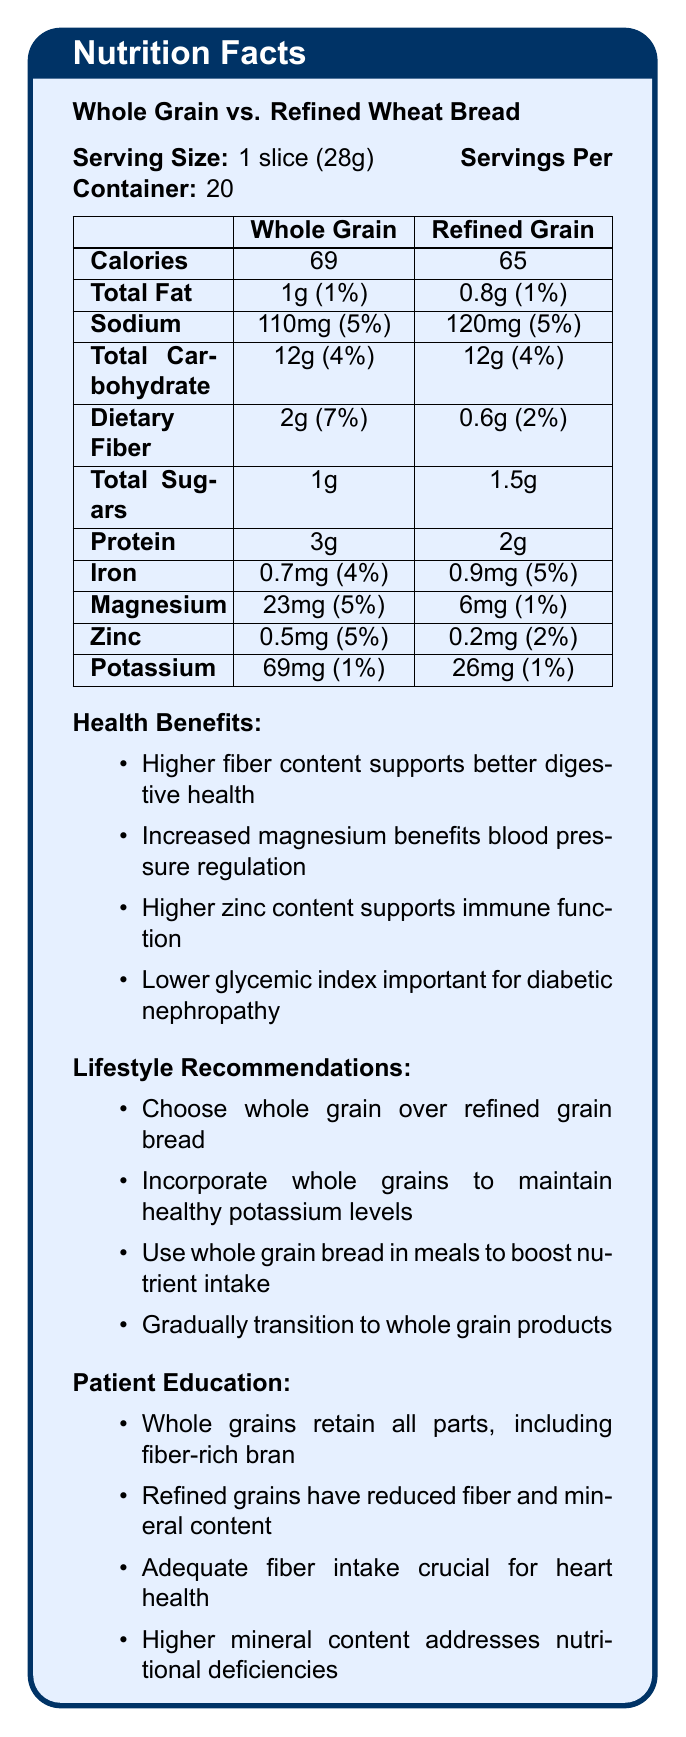what is the serving size for both whole grain and refined grain bread? The serving size is clearly stated as 1 slice (28g) for both whole grain and refined grain bread at the beginning of the document.
Answer: 1 slice (28g) how much dietary fiber does whole grain bread contain per serving? The document states that whole grain bread contains 2g of dietary fiber per serving in the Nutrition Facts table.
Answer: 2g how many calories are in a serving of refined grain bread? The Nutrition Facts table indicates that a serving of refined grain bread contains 65 calories.
Answer: 65 calories what percentage of daily magnesium intake does whole grain bread provide? The document states that whole grain bread provides 5% of the daily value of magnesium per serving.
Answer: 5% compare the sodium content of whole grain bread with refined grain bread. The Nutrition Facts table shows that whole grain bread contains 110mg of sodium (5% of the daily value), whereas refined grain bread contains 120mg of sodium (5% of the daily value).
Answer: Whole grain bread: 110mg (5%), Refined grain bread: 120mg (5%) which type of bread is recommended for maintaining healthy potassium levels? A. Whole grain bread B. Refined grain bread C. Both D. Neither Under Lifestyle Recommendations, it is suggested to incorporate whole grain products into meals to help maintain healthy potassium levels.
Answer: A. Whole grain bread what is one of the health benefits of choosing whole grain bread over refined grain bread? A. Higher sugar content B. Higher glycemic index C. Better digestive health D. Higher calorie content The Health Benefits section highlights that the higher fiber content in whole grain bread supports better digestive health.
Answer: C. Better digestive health does whole grain bread provide more protein than refined grain bread? According to the Nutrition Facts table, whole grain bread contains 3g of protein per serving, while refined grain bread contains 2g of protein.
Answer: Yes what are some points covered in the Patient Education section about whole grain and refined grain products? The Patient Education section emphasizes the retention of bran and germ in whole grains, the reduction of fiber and minerals in refined grains, the importance of fiber for heart health, and the mineral benefits for kidney patients.
Answer: Whole grains retain fiber-rich bran and nutrient-dense germ, whereas refined grains have these parts removed, reducing fiber and mineral content; adequate fiber intake helps maintain healthy cholesterol levels; higher mineral content in whole grains helps address deficiencies in chronic kidney disease patients. what type of bread has a lower glycemic index and why is this important for some patients? The Health Benefits section notes that whole grain bread has a lower glycemic index which is crucial for patients with diabetic nephropathy.
Answer: Whole grain bread; important for diabetic nephropathy patients how much iron does refined grain bread contain per serving? The document states that refined grain bread contains 0.9mg of iron per serving, which is 5% of the daily value.
Answer: 0.9mg (5%) can the exact ratios of serving size to protein content for both types of bread be determined from the document? While the protein content per serving is provided, the document does not provide the data necessary to calculate the exact ratio accurately beyond simple division.
Answer: Not enough information summarize the main differences between whole grain and refined grain bread as presented in the document. The document contrasts the nutritional content and health benefits of whole grain versus refined grain bread, focusing on whole grain’s superior fiber, mineral content, and lower glycemic index. It offers health benefits, lifestyle recommendations, and educational points aimed at promoting whole grain bread for kidney health and overall wellness.
Answer: Whole grain bread has higher fiber, magnesium, zinc, and potassium content compared to refined grain bread. It is recommended for better digestive health, blood pressure regulation, immune support, and has a lower glycemic index, making it a better choice for diabetic nephropathy patients. The document also suggests lifestyle adjustments to gradually incorporate whole grains into the diet. how much total carbohydrate does one serving of both whole grain and refined grain bread contain? The Nutrition Facts table shows that both types of bread contain 12g of total carbohydrates per serving.
Answer: 12g 